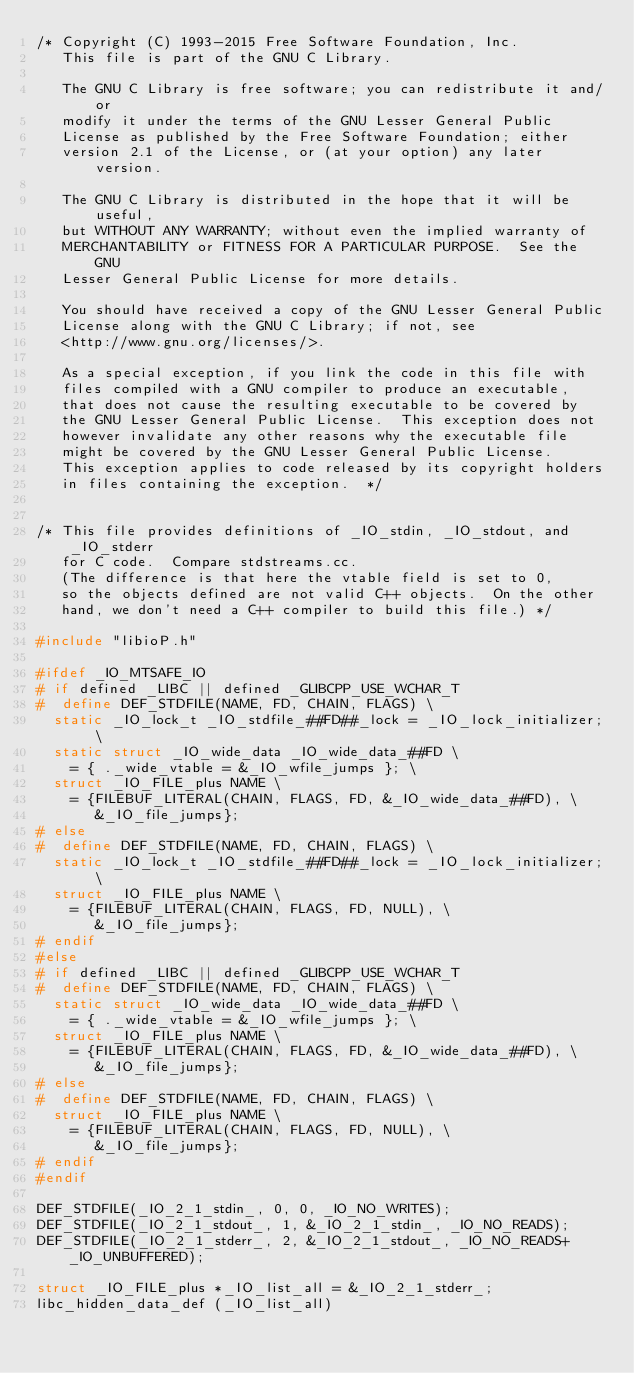Convert code to text. <code><loc_0><loc_0><loc_500><loc_500><_C_>/* Copyright (C) 1993-2015 Free Software Foundation, Inc.
   This file is part of the GNU C Library.

   The GNU C Library is free software; you can redistribute it and/or
   modify it under the terms of the GNU Lesser General Public
   License as published by the Free Software Foundation; either
   version 2.1 of the License, or (at your option) any later version.

   The GNU C Library is distributed in the hope that it will be useful,
   but WITHOUT ANY WARRANTY; without even the implied warranty of
   MERCHANTABILITY or FITNESS FOR A PARTICULAR PURPOSE.  See the GNU
   Lesser General Public License for more details.

   You should have received a copy of the GNU Lesser General Public
   License along with the GNU C Library; if not, see
   <http://www.gnu.org/licenses/>.

   As a special exception, if you link the code in this file with
   files compiled with a GNU compiler to produce an executable,
   that does not cause the resulting executable to be covered by
   the GNU Lesser General Public License.  This exception does not
   however invalidate any other reasons why the executable file
   might be covered by the GNU Lesser General Public License.
   This exception applies to code released by its copyright holders
   in files containing the exception.  */


/* This file provides definitions of _IO_stdin, _IO_stdout, and _IO_stderr
   for C code.  Compare stdstreams.cc.
   (The difference is that here the vtable field is set to 0,
   so the objects defined are not valid C++ objects.  On the other
   hand, we don't need a C++ compiler to build this file.) */

#include "libioP.h"

#ifdef _IO_MTSAFE_IO
# if defined _LIBC || defined _GLIBCPP_USE_WCHAR_T
#  define DEF_STDFILE(NAME, FD, CHAIN, FLAGS) \
  static _IO_lock_t _IO_stdfile_##FD##_lock = _IO_lock_initializer; \
  static struct _IO_wide_data _IO_wide_data_##FD \
    = { ._wide_vtable = &_IO_wfile_jumps }; \
  struct _IO_FILE_plus NAME \
    = {FILEBUF_LITERAL(CHAIN, FLAGS, FD, &_IO_wide_data_##FD), \
       &_IO_file_jumps};
# else
#  define DEF_STDFILE(NAME, FD, CHAIN, FLAGS) \
  static _IO_lock_t _IO_stdfile_##FD##_lock = _IO_lock_initializer; \
  struct _IO_FILE_plus NAME \
    = {FILEBUF_LITERAL(CHAIN, FLAGS, FD, NULL), \
       &_IO_file_jumps};
# endif
#else
# if defined _LIBC || defined _GLIBCPP_USE_WCHAR_T
#  define DEF_STDFILE(NAME, FD, CHAIN, FLAGS) \
  static struct _IO_wide_data _IO_wide_data_##FD \
    = { ._wide_vtable = &_IO_wfile_jumps }; \
  struct _IO_FILE_plus NAME \
    = {FILEBUF_LITERAL(CHAIN, FLAGS, FD, &_IO_wide_data_##FD), \
       &_IO_file_jumps};
# else
#  define DEF_STDFILE(NAME, FD, CHAIN, FLAGS) \
  struct _IO_FILE_plus NAME \
    = {FILEBUF_LITERAL(CHAIN, FLAGS, FD, NULL), \
       &_IO_file_jumps};
# endif
#endif

DEF_STDFILE(_IO_2_1_stdin_, 0, 0, _IO_NO_WRITES);
DEF_STDFILE(_IO_2_1_stdout_, 1, &_IO_2_1_stdin_, _IO_NO_READS);
DEF_STDFILE(_IO_2_1_stderr_, 2, &_IO_2_1_stdout_, _IO_NO_READS+_IO_UNBUFFERED);

struct _IO_FILE_plus *_IO_list_all = &_IO_2_1_stderr_;
libc_hidden_data_def (_IO_list_all)
</code> 